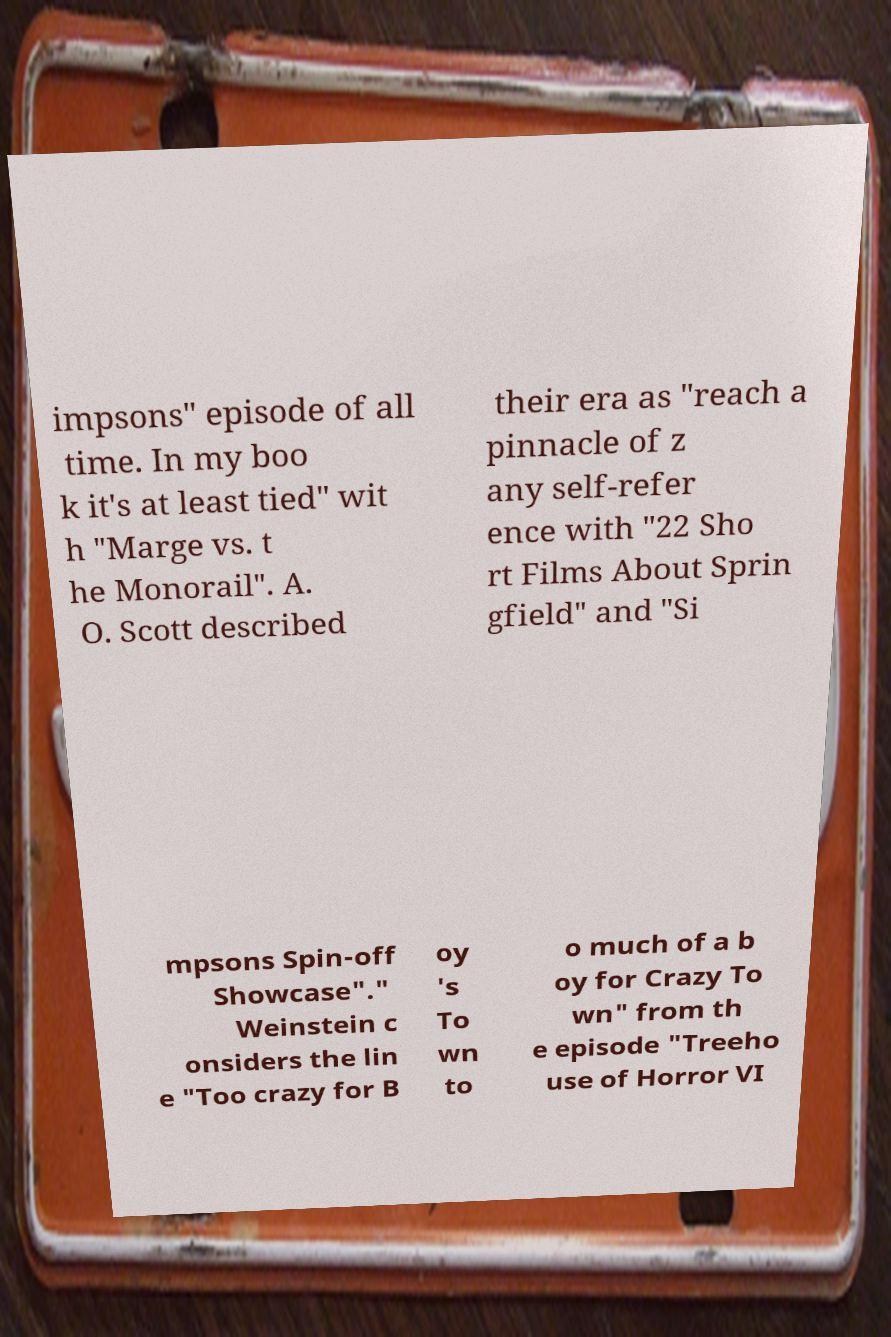Could you assist in decoding the text presented in this image and type it out clearly? impsons" episode of all time. In my boo k it's at least tied" wit h "Marge vs. t he Monorail". A. O. Scott described their era as "reach a pinnacle of z any self-refer ence with "22 Sho rt Films About Sprin gfield" and "Si mpsons Spin-off Showcase"." Weinstein c onsiders the lin e "Too crazy for B oy 's To wn to o much of a b oy for Crazy To wn" from th e episode "Treeho use of Horror VI 